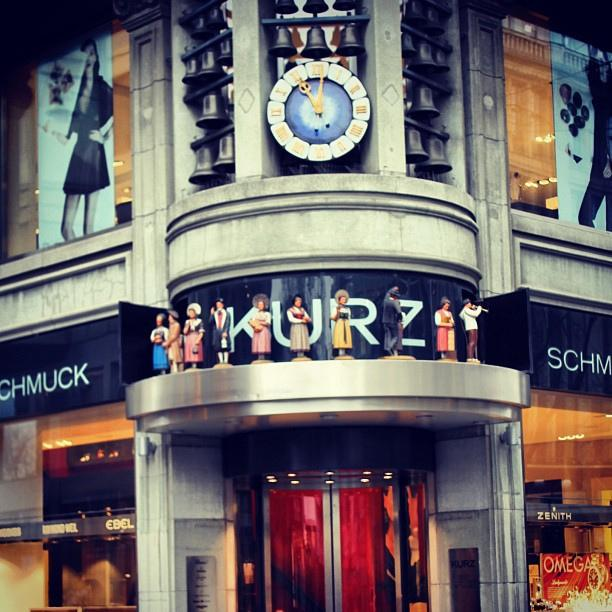What sort of wearable item is available for sale within? watch 